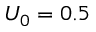Convert formula to latex. <formula><loc_0><loc_0><loc_500><loc_500>U _ { 0 } = 0 . 5</formula> 